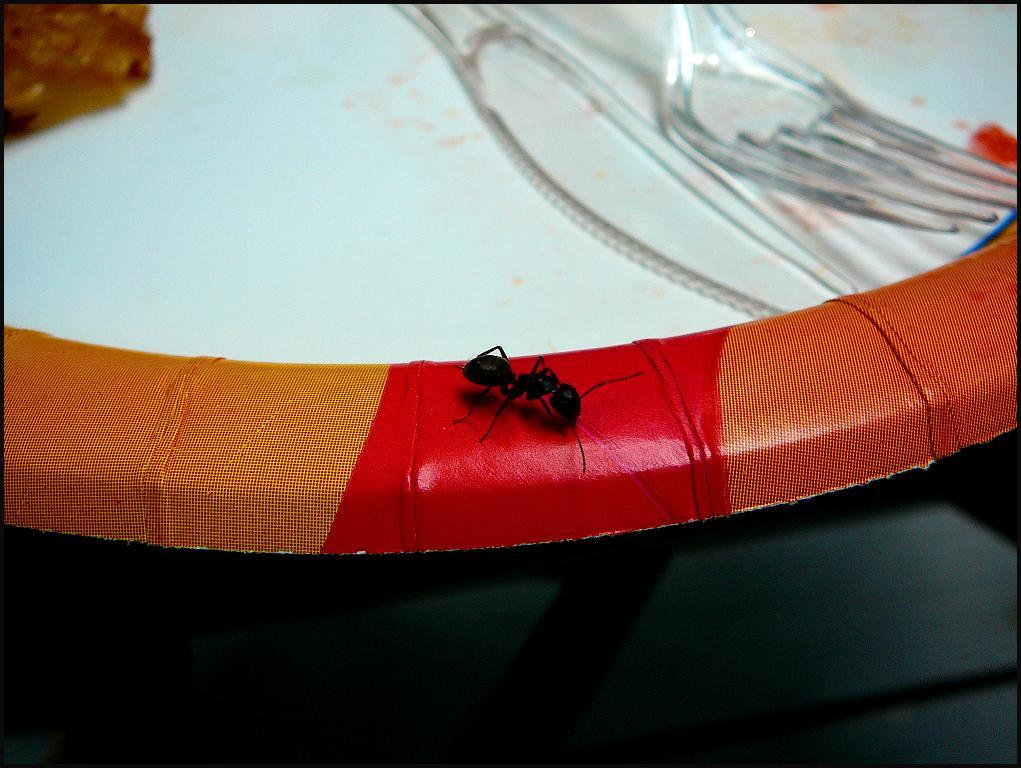What is present on the plate in the image? There is an ant on the plate in the image. What utensils can be seen in the image? There is a knife and a fork in the image. What else is present on the plate besides the ant? There is no other information about the plate's contents, so we cannot determine what else is present. Can you describe the object in the image? Unfortunately, there is not enough information about the object to provide a description. How does the tramp use the knife in the image? There is no tramp present in the image, so we cannot answer this question. What type of oil is visible on the plate in the image? There is no oil present on the plate in the image. 